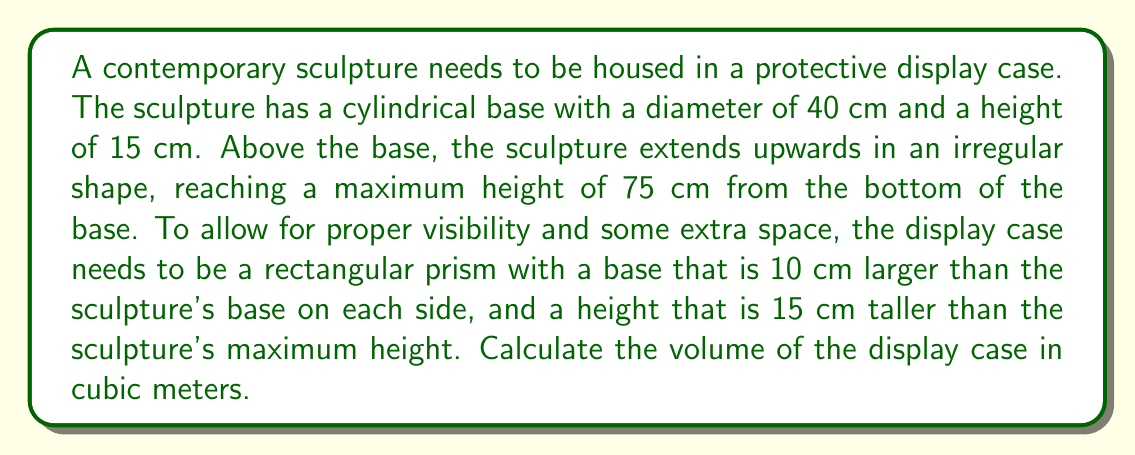Can you solve this math problem? Let's approach this problem step-by-step:

1) First, we need to determine the dimensions of the display case:

   - Base width and length:
     The sculpture's base diameter is 40 cm.
     We need to add 10 cm on each side, so we add 20 cm to the diameter.
     $$40 \text{ cm} + 20 \text{ cm} = 60 \text{ cm}$$

   - Height:
     The sculpture's maximum height is 75 cm.
     We need to add 15 cm to this height.
     $$75 \text{ cm} + 15 \text{ cm} = 90 \text{ cm}$$

2) Now we have the dimensions of our rectangular prism display case:
   60 cm × 60 cm × 90 cm

3) To calculate the volume of a rectangular prism, we use the formula:
   $$V = l \times w \times h$$
   Where $V$ is volume, $l$ is length, $w$ is width, and $h$ is height.

4) Plugging in our values:
   $$V = 60 \text{ cm} \times 60 \text{ cm} \times 90 \text{ cm} = 324,000 \text{ cm}^3$$

5) The question asks for the volume in cubic meters. We need to convert from cm³ to m³:
   $$324,000 \text{ cm}^3 = 324,000 \times (0.01 \text{ m})^3 = 324,000 \times 0.000001 \text{ m}^3 = 0.324 \text{ m}^3$$

Therefore, the volume of the display case is 0.324 cubic meters.
Answer: 0.324 m³ 